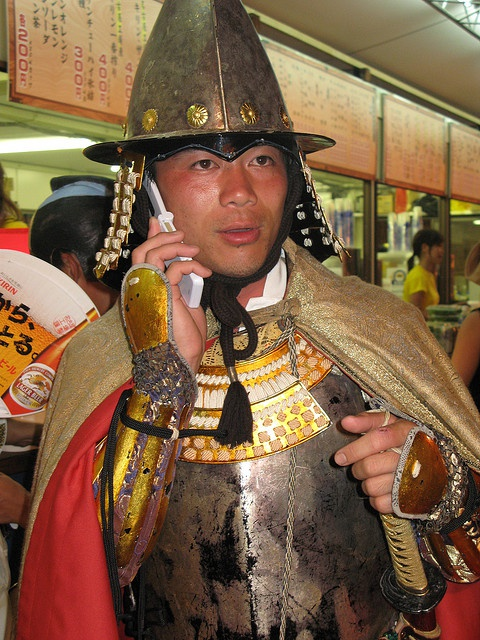Describe the objects in this image and their specific colors. I can see people in olive, black, gray, and maroon tones, people in olive, black, maroon, and gray tones, bottle in olive, brown, gray, and red tones, people in olive, black, and maroon tones, and people in olive, maroon, brown, and black tones in this image. 